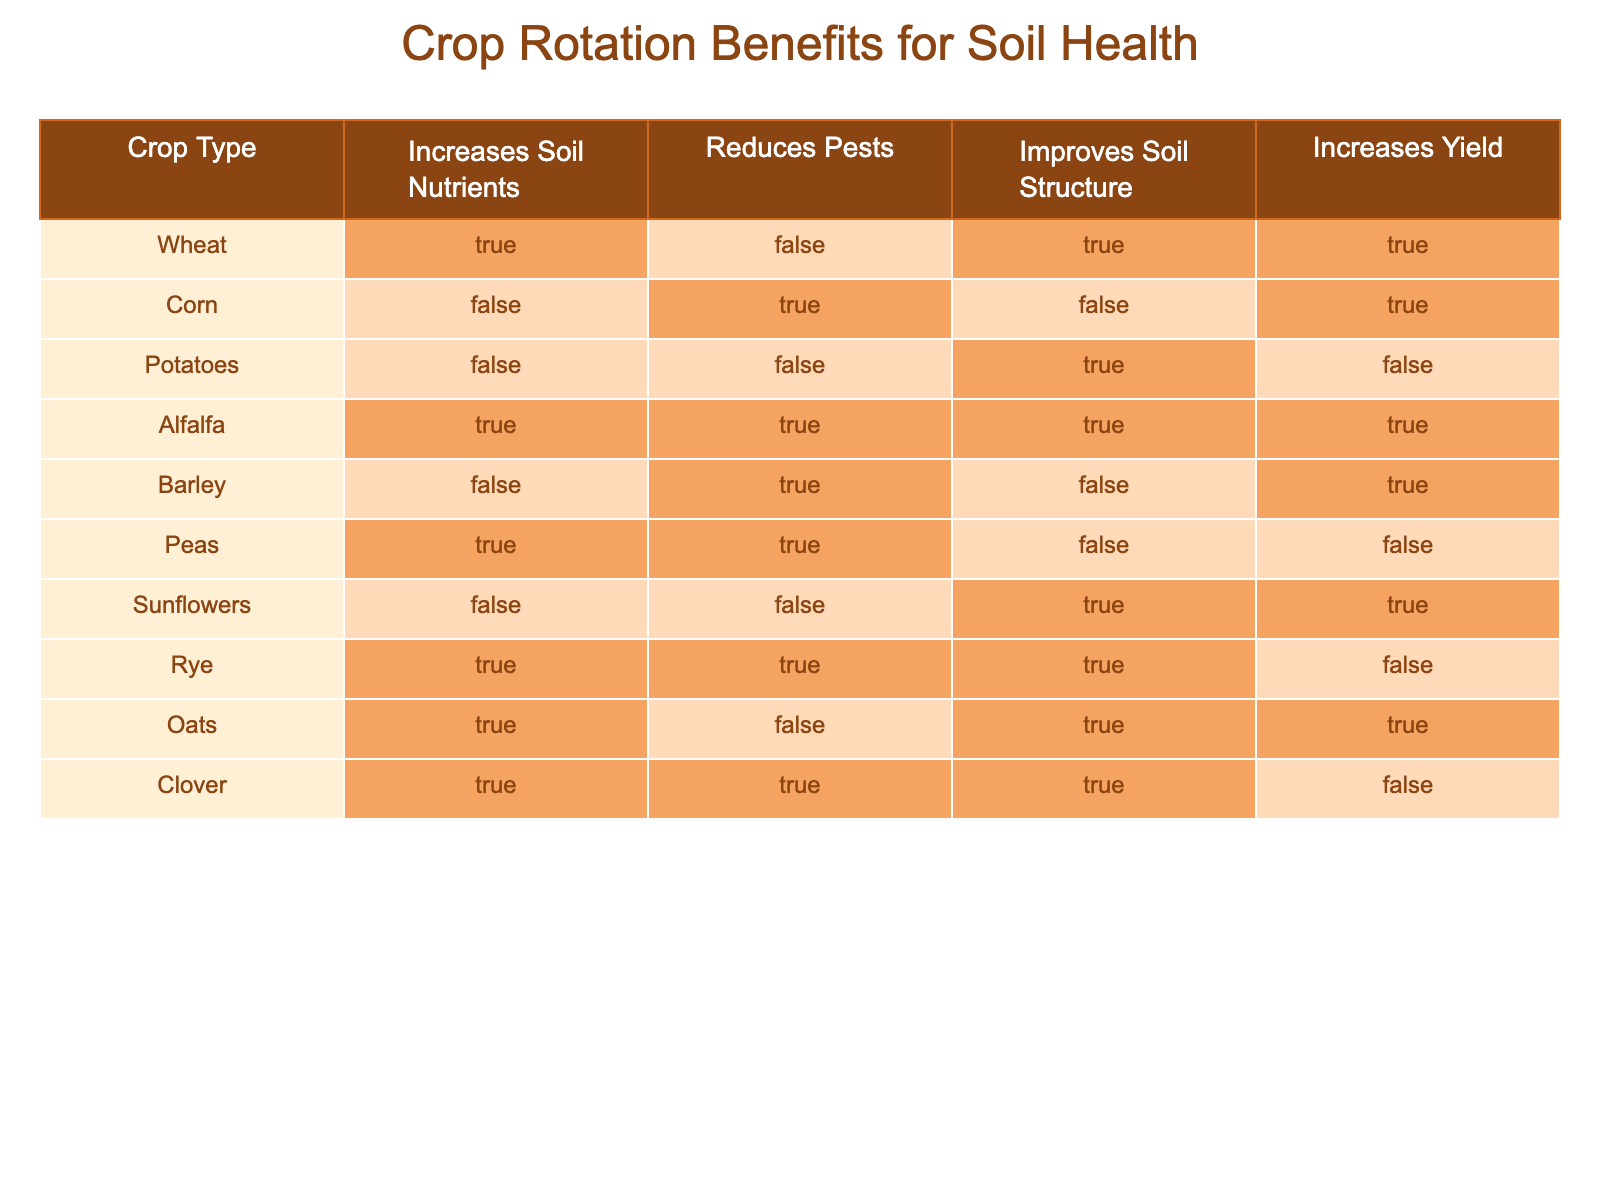What crop increases soil nutrients the most? Alfalfa, Wheat, Peas, Oats, Clover, and Rye all increase soil nutrients as they are marked TRUE for that feature. Out of these, Alfalfa is unique as it also offers pest reduction and improvement in soil structure.
Answer: Alfalfa Does corn improve soil structure? In the table, corn is marked FALSE for improving soil structure, indicating that it does not contribute positively in that regard.
Answer: No Which crops both reduce pests and improve soil structure? We can examine the table for crops that are marked TRUE in both the "Reduces Pests" and "Improves Soil Structure" columns. The crops that meet this criteria are Alfalfa and Rye.
Answer: Alfalfa, Rye How many crops increase yield while also improving soil structure? To find this, cross-reference the number of crops that are marked TRUE for both "Increases Yield" and "Improves Soil Structure". The crops meeting both conditions are Wheat, Corn, Potatoes, and Oats. Thus, there are four such crops.
Answer: 4 Is there any crop that does not increase yield yet improves soil structure? Reviewing the table, we find Potatoes, with a TRUE mark for "Improves Soil Structure", but FALSE for "Increases Yield". This shows that this crop does not lead to higher yield despite the positive impact on soil structure.
Answer: Yes How many crops increase both soil nutrients and are also capable of reducing pests? The crops that are marked TRUE for both "Increases Soil Nutrients" and "Reduces Pests" are Alfalfa and Peas. This means there are two crops that fulfill these criteria.
Answer: 2 Which crop has the least benefits for soil health based on the table? By checking the table, Potatoes do not increase nutrients, reduce pests, or increase yield, having only a TRUE mark for improving soil structure. Therefore, it can be seen as having the least benefits overall.
Answer: Potatoes Are there any crops that do not improve soil structure but increase yield? The crops that show FALSE for "Improves Soil Structure" and TRUE for "Increases Yield" would need examining. Based on the table, Corn and Barley fall into this category.
Answer: Corn, Barley 